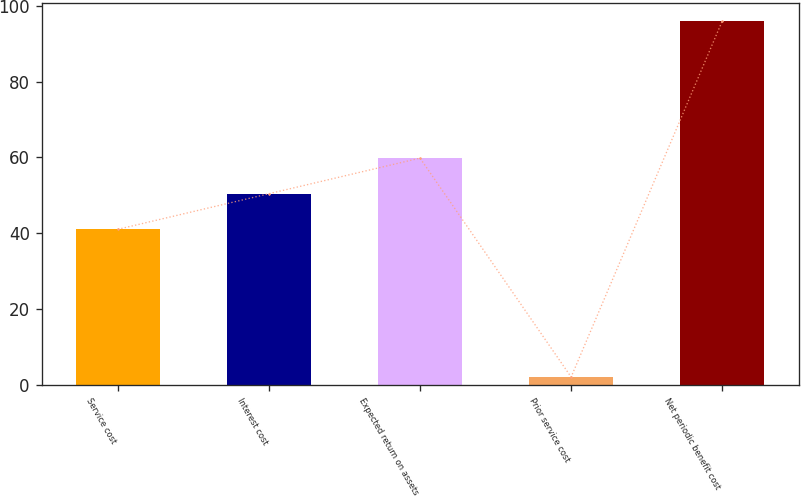Convert chart to OTSL. <chart><loc_0><loc_0><loc_500><loc_500><bar_chart><fcel>Service cost<fcel>Interest cost<fcel>Expected return on assets<fcel>Prior service cost<fcel>Net periodic benefit cost<nl><fcel>41<fcel>50.4<fcel>59.8<fcel>2<fcel>96<nl></chart> 